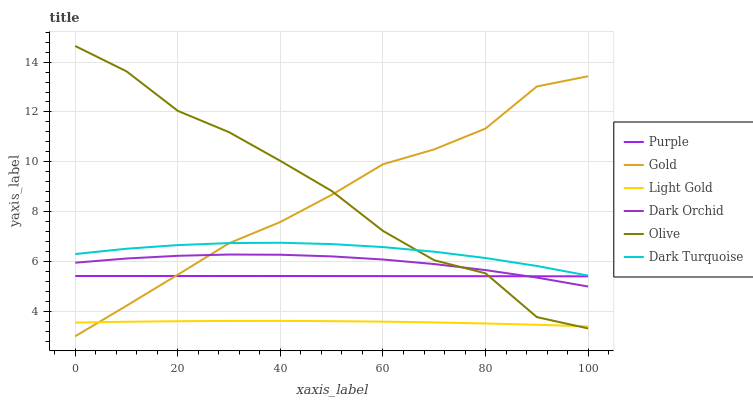Does Light Gold have the minimum area under the curve?
Answer yes or no. Yes. Does Olive have the maximum area under the curve?
Answer yes or no. Yes. Does Purple have the minimum area under the curve?
Answer yes or no. No. Does Purple have the maximum area under the curve?
Answer yes or no. No. Is Purple the smoothest?
Answer yes or no. Yes. Is Olive the roughest?
Answer yes or no. Yes. Is Dark Turquoise the smoothest?
Answer yes or no. No. Is Dark Turquoise the roughest?
Answer yes or no. No. Does Purple have the lowest value?
Answer yes or no. No. Does Olive have the highest value?
Answer yes or no. Yes. Does Purple have the highest value?
Answer yes or no. No. Is Dark Orchid less than Dark Turquoise?
Answer yes or no. Yes. Is Dark Turquoise greater than Light Gold?
Answer yes or no. Yes. Does Gold intersect Light Gold?
Answer yes or no. Yes. Is Gold less than Light Gold?
Answer yes or no. No. Is Gold greater than Light Gold?
Answer yes or no. No. Does Dark Orchid intersect Dark Turquoise?
Answer yes or no. No. 